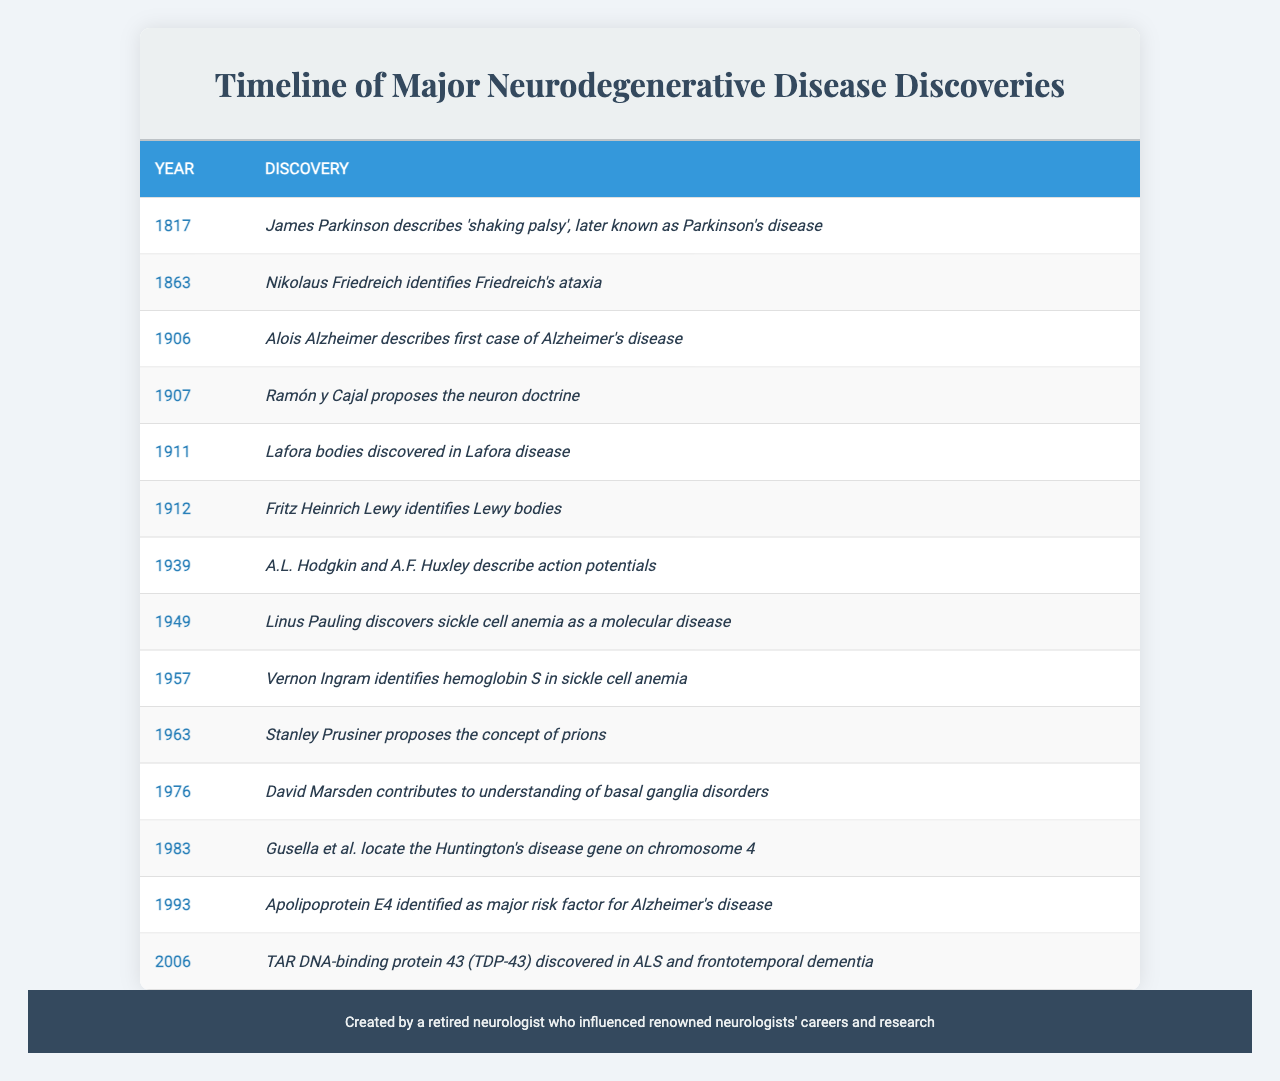What year did James Parkinson describe "shaking palsy"? According to the table, James Parkinson described "shaking palsy" in the year 1817.
Answer: 1817 Who identified Friedreich's ataxia? The table shows that Nikolaus Friedreich identified Friedreich's ataxia in 1863.
Answer: Nikolaus Friedreich What was proposed by Ramón y Cajal in relation to neurodegenerative diseases? Ramón y Cajal proposed the neuron doctrine in 1907, as indicated in the table.
Answer: Neuron doctrine Which discovery related to Alzheimer's disease is attributed to Apolipoprotein E4? The table mentions that apolipoprotein E4 was identified as a major risk factor for Alzheimer's disease in 1993.
Answer: Major risk factor How many years separate the discoveries of Lafora bodies and Lewy bodies? The discovery of Lafora bodies occurred in 1911 and Lewy bodies were identified in 1912. The time difference is 1 year (1912 - 1911).
Answer: 1 year Which discovery occurred most recently in the timeline? The last entry in the table indicates that TAR DNA-binding protein 43 (TDP-43) was discovered in 2006.
Answer: 2006 Was the discovery that Vernon Ingram identified hemoglobin S earlier or later than 1960? The table shows that Vernon Ingram identified hemoglobin S in 1957, which is earlier than 1960.
Answer: Earlier List all the discoveries made in the 20th century, sorted by year. The discoveries made in the 20th century according to the table are: "Alois Alzheimer describes first case of Alzheimer's disease" (1906), "Ramón y Cajal proposes the neuron doctrine" (1907), "Lafora bodies discovered in Lafora disease" (1911), "Fritz Heinrich Lewy identifies Lewy bodies" (1912), "A.L. Hodgkin and A.F. Huxley describe action potentials" (1939), "Linus Pauling discovers sickle cell anemia as a molecular disease" (1949), "Vernon Ingram identifies hemoglobin S in sickle cell anemia" (1957), "Stanley Prusiner proposes the concept of prions" (1983), "Apolipoprotein E4 identified as major risk factor for Alzheimer's disease" (1993), and "TAR DNA-binding protein 43 discovered in ALS and frontotemporal dementia" (2006).
Answer: List provided What was the key contribution of David Marsden mentioned in the table? The table notes that David Marsden contributed to the understanding of basal ganglia disorders, but does not specify a particular year for his contribution.
Answer: Understanding of basal ganglia disorders Determine the span of years during which the discoveries relevant to the timeline were made. The earliest discovery was in 1817 and the most recent was in 2006. To find the span of years, subtract 1817 from 2006, which equals 189 years.
Answer: 189 years How many discoveries were made before 1950? According to the table, the discoveries made before 1950 include those from 1817 (James Parkinson), 1863 (Nikolaus Friedreich), 1906 (Alois Alzheimer), 1907 (Ramón y Cajal), 1911 (Lafora bodies), 1912 (Lewy bodies), 1939 (Hodgkin and Huxley), and 1949 (Pauling), totaling 8 discoveries.
Answer: 8 discoveries 